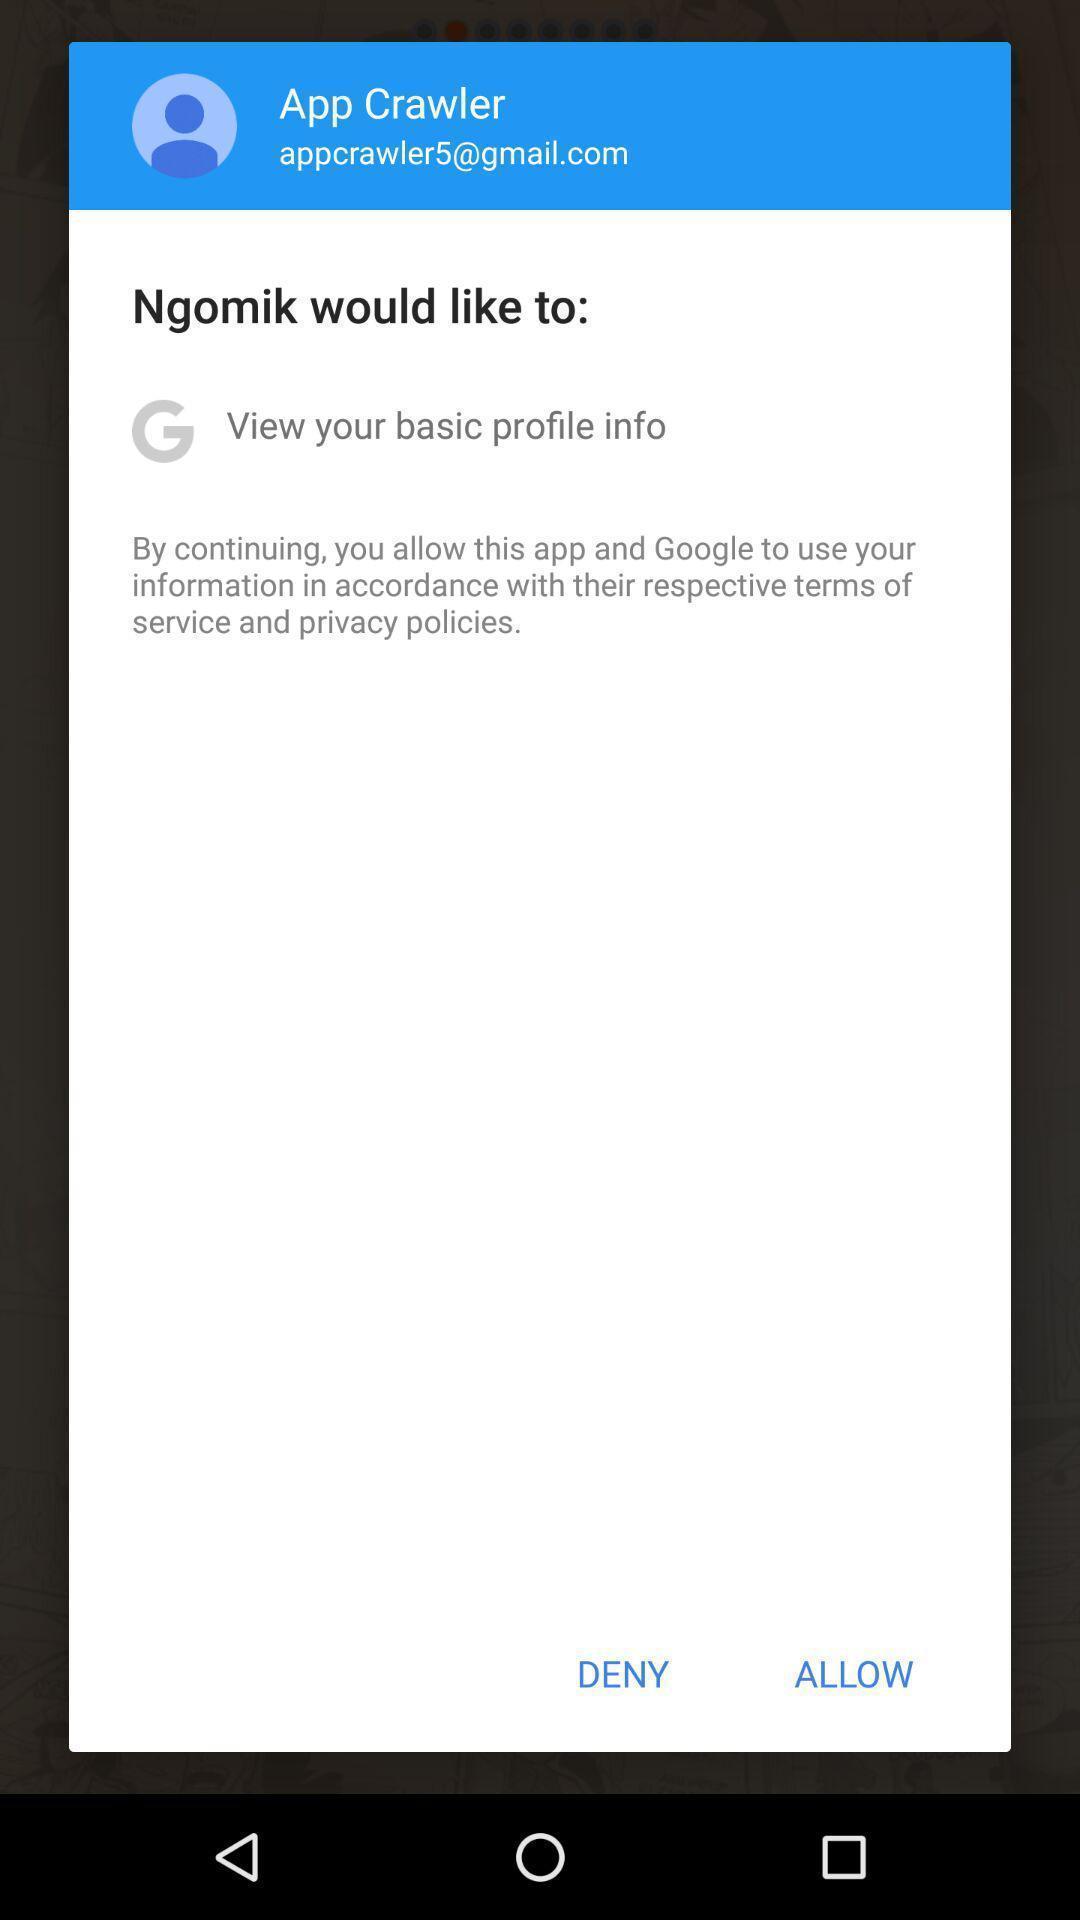Tell me what you see in this picture. Popup showing deny and allow option. 